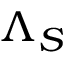Convert formula to latex. <formula><loc_0><loc_0><loc_500><loc_500>\Lambda _ { S }</formula> 